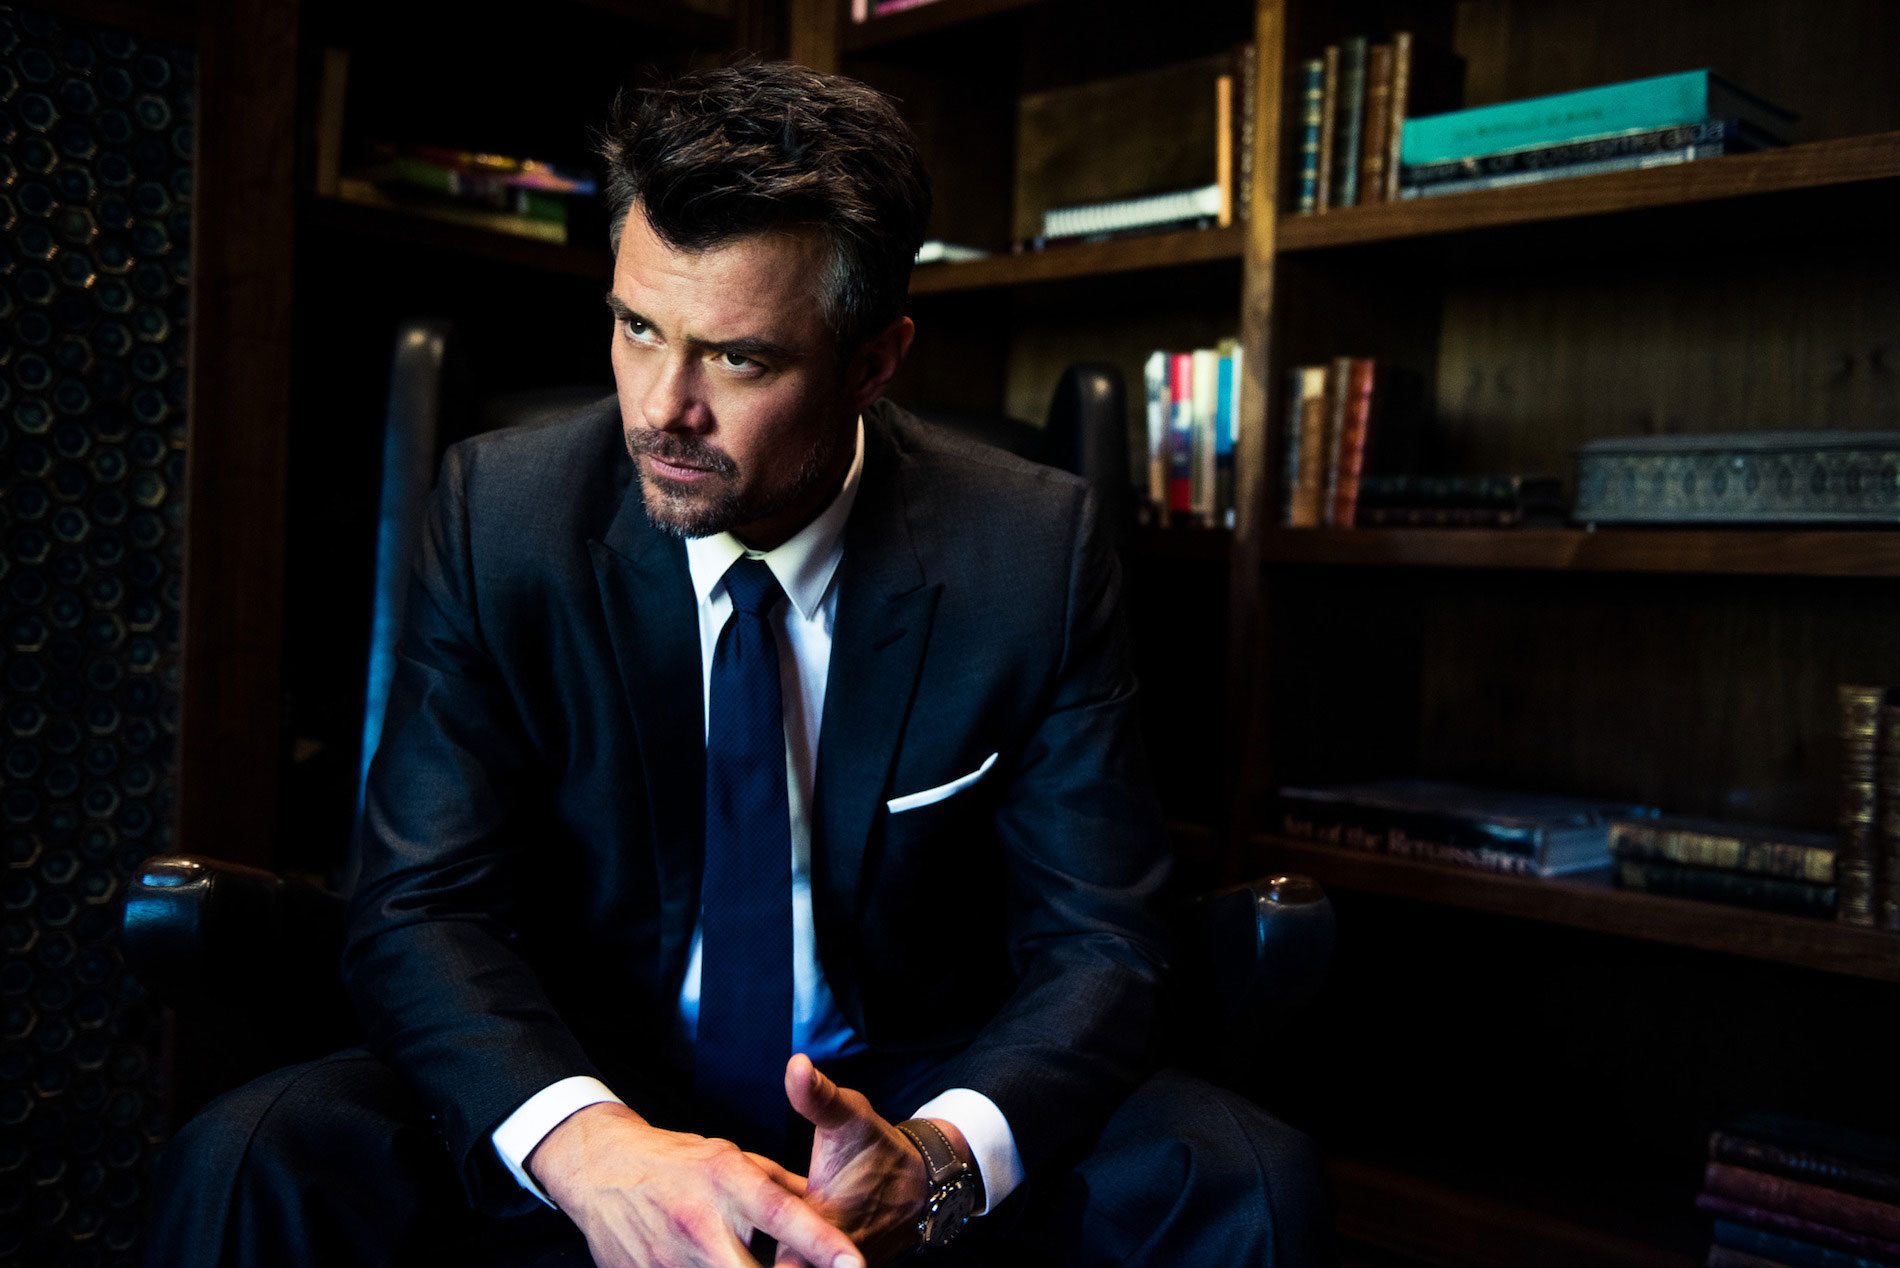Imagine this man could speak to us now; what might he say? 'I've been thinking about the choices I've made. Some were easy, others came with a heavy price. This room, these books—they're a sanctuary, a place to ponder what lies ahead as much as what lies behind.' What do you think is his profession, based on the image? Based on his formal attire and the sophisticated setting, he might be a professional such as a lawyer, a businessman, or perhaps an academic. The serious demeanor and the library-like environment suggest he holds a position that requires thoughtful decision-making. 